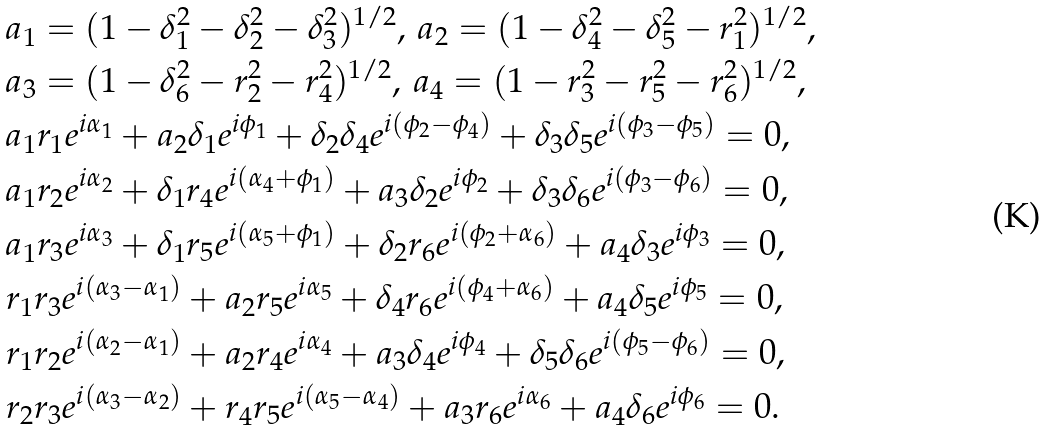Convert formula to latex. <formula><loc_0><loc_0><loc_500><loc_500>& a _ { 1 } = ( 1 - \delta ^ { 2 } _ { 1 } - \delta ^ { 2 } _ { 2 } - \delta ^ { 2 } _ { 3 } ) ^ { 1 / 2 } , \, a _ { 2 } = ( 1 - \delta ^ { 2 } _ { 4 } - \delta ^ { 2 } _ { 5 } - r ^ { 2 } _ { 1 } ) ^ { 1 / 2 } , \\ & a _ { 3 } = ( 1 - \delta ^ { 2 } _ { 6 } - r ^ { 2 } _ { 2 } - r ^ { 2 } _ { 4 } ) ^ { 1 / 2 } , \, a _ { 4 } = ( 1 - r ^ { 2 } _ { 3 } - r ^ { 2 } _ { 5 } - r ^ { 2 } _ { 6 } ) ^ { 1 / 2 } , \\ & a _ { 1 } r _ { 1 } e ^ { i \alpha _ { 1 } } + a _ { 2 } \delta _ { 1 } e ^ { i \phi _ { 1 } } + \delta _ { 2 } \delta _ { 4 } e ^ { i ( \phi _ { 2 } - \phi _ { 4 } ) } + \delta _ { 3 } \delta _ { 5 } e ^ { i ( \phi _ { 3 } - \phi _ { 5 } ) } = 0 , \\ & a _ { 1 } r _ { 2 } e ^ { i \alpha _ { 2 } } + \delta _ { 1 } r _ { 4 } e ^ { i ( \alpha _ { 4 } + \phi _ { 1 } ) } + a _ { 3 } \delta _ { 2 } e ^ { i \phi _ { 2 } } + \delta _ { 3 } \delta _ { 6 } e ^ { i ( \phi _ { 3 } - \phi _ { 6 } ) } = 0 , \\ & a _ { 1 } r _ { 3 } e ^ { i \alpha _ { 3 } } + \delta _ { 1 } r _ { 5 } e ^ { i ( \alpha _ { 5 } + \phi _ { 1 } ) } + \delta _ { 2 } r _ { 6 } e ^ { i ( \phi _ { 2 } + \alpha _ { 6 } ) } + a _ { 4 } \delta _ { 3 } e ^ { i \phi _ { 3 } } = 0 , \\ & r _ { 1 } r _ { 3 } e ^ { i ( \alpha _ { 3 } - \alpha _ { 1 } ) } + a _ { 2 } r _ { 5 } e ^ { i \alpha _ { 5 } } + \delta _ { 4 } r _ { 6 } e ^ { i ( \phi _ { 4 } + \alpha _ { 6 } ) } + a _ { 4 } \delta _ { 5 } e ^ { i \phi _ { 5 } } = 0 , \\ & r _ { 1 } r _ { 2 } e ^ { i ( \alpha _ { 2 } - \alpha _ { 1 } ) } + a _ { 2 } r _ { 4 } e ^ { i \alpha _ { 4 } } + a _ { 3 } \delta _ { 4 } e ^ { i \phi _ { 4 } } + \delta _ { 5 } \delta _ { 6 } e ^ { i ( \phi _ { 5 } - \phi _ { 6 } ) } = 0 , \\ & r _ { 2 } r _ { 3 } e ^ { i ( \alpha _ { 3 } - \alpha _ { 2 } ) } + r _ { 4 } r _ { 5 } e ^ { i ( \alpha _ { 5 } - \alpha _ { 4 } ) } + a _ { 3 } r _ { 6 } e ^ { i \alpha _ { 6 } } + a _ { 4 } \delta _ { 6 } e ^ { i \phi _ { 6 } } = 0 .</formula> 